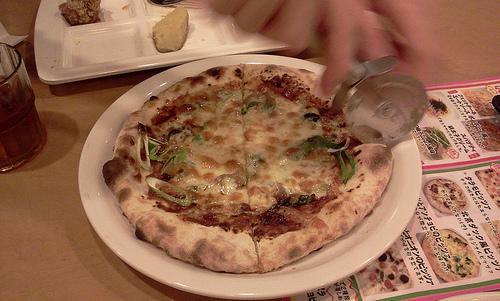Question: what is the main focus of this photo?
Choices:
A. Tacos.
B. Spaghetti.
C. A pizza.
D. Salad.
Answer with the letter. Answer: C Question: how many slices has the pizza been cut into?
Choices:
A. Four.
B. Three.
C. Two.
D. Six.
Answer with the letter. Answer: A Question: what is the plate sitting on?
Choices:
A. Napkin.
B. A menu.
C. Table.
D. Placemat.
Answer with the letter. Answer: B Question: where was this photo taken?
Choices:
A. A zoo.
B. A theatre.
C. A restaurant.
D. A school.
Answer with the letter. Answer: C 